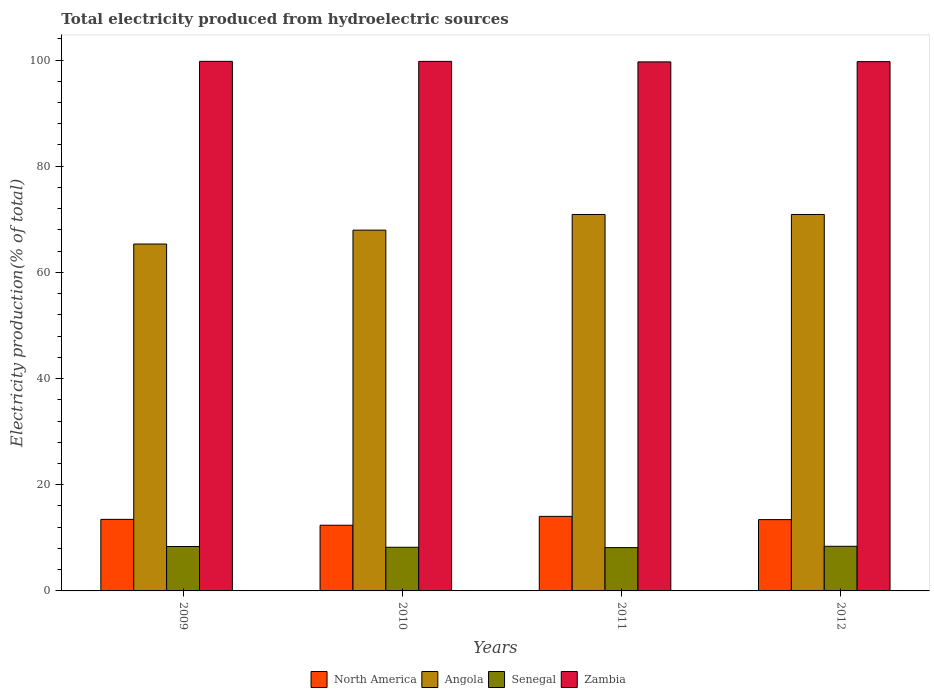How many different coloured bars are there?
Offer a very short reply. 4. How many groups of bars are there?
Offer a very short reply. 4. How many bars are there on the 2nd tick from the right?
Give a very brief answer. 4. What is the label of the 3rd group of bars from the left?
Your response must be concise. 2011. In how many cases, is the number of bars for a given year not equal to the number of legend labels?
Offer a terse response. 0. What is the total electricity produced in Senegal in 2011?
Give a very brief answer. 8.16. Across all years, what is the maximum total electricity produced in Angola?
Provide a succinct answer. 70.91. Across all years, what is the minimum total electricity produced in North America?
Your answer should be compact. 12.37. In which year was the total electricity produced in Senegal maximum?
Your response must be concise. 2012. In which year was the total electricity produced in Angola minimum?
Give a very brief answer. 2009. What is the total total electricity produced in Zambia in the graph?
Give a very brief answer. 398.84. What is the difference between the total electricity produced in Senegal in 2009 and that in 2010?
Give a very brief answer. 0.14. What is the difference between the total electricity produced in North America in 2010 and the total electricity produced in Zambia in 2012?
Keep it short and to the point. -87.32. What is the average total electricity produced in Angola per year?
Your answer should be very brief. 68.78. In the year 2011, what is the difference between the total electricity produced in Angola and total electricity produced in Senegal?
Your response must be concise. 62.75. In how many years, is the total electricity produced in North America greater than 8 %?
Offer a terse response. 4. What is the ratio of the total electricity produced in Angola in 2010 to that in 2012?
Your response must be concise. 0.96. Is the difference between the total electricity produced in Angola in 2010 and 2012 greater than the difference between the total electricity produced in Senegal in 2010 and 2012?
Your answer should be compact. No. What is the difference between the highest and the second highest total electricity produced in Zambia?
Your response must be concise. 0.01. What is the difference between the highest and the lowest total electricity produced in North America?
Your answer should be very brief. 1.67. Is the sum of the total electricity produced in Zambia in 2009 and 2012 greater than the maximum total electricity produced in Angola across all years?
Your response must be concise. Yes. What does the 3rd bar from the left in 2010 represents?
Your response must be concise. Senegal. What does the 3rd bar from the right in 2012 represents?
Keep it short and to the point. Angola. Is it the case that in every year, the sum of the total electricity produced in Angola and total electricity produced in Senegal is greater than the total electricity produced in North America?
Offer a terse response. Yes. How many bars are there?
Give a very brief answer. 16. How many years are there in the graph?
Make the answer very short. 4. Does the graph contain any zero values?
Keep it short and to the point. No. Does the graph contain grids?
Your response must be concise. No. Where does the legend appear in the graph?
Your answer should be very brief. Bottom center. How many legend labels are there?
Make the answer very short. 4. How are the legend labels stacked?
Provide a short and direct response. Horizontal. What is the title of the graph?
Your answer should be very brief. Total electricity produced from hydroelectric sources. Does "Cyprus" appear as one of the legend labels in the graph?
Give a very brief answer. No. What is the Electricity production(% of total) in North America in 2009?
Your answer should be compact. 13.48. What is the Electricity production(% of total) of Angola in 2009?
Offer a very short reply. 65.34. What is the Electricity production(% of total) in Senegal in 2009?
Provide a succinct answer. 8.36. What is the Electricity production(% of total) in Zambia in 2009?
Offer a terse response. 99.75. What is the Electricity production(% of total) of North America in 2010?
Your answer should be very brief. 12.37. What is the Electricity production(% of total) in Angola in 2010?
Provide a short and direct response. 67.96. What is the Electricity production(% of total) in Senegal in 2010?
Offer a very short reply. 8.22. What is the Electricity production(% of total) in Zambia in 2010?
Provide a succinct answer. 99.74. What is the Electricity production(% of total) in North America in 2011?
Your response must be concise. 14.04. What is the Electricity production(% of total) in Angola in 2011?
Make the answer very short. 70.91. What is the Electricity production(% of total) of Senegal in 2011?
Ensure brevity in your answer.  8.16. What is the Electricity production(% of total) of Zambia in 2011?
Give a very brief answer. 99.65. What is the Electricity production(% of total) of North America in 2012?
Provide a short and direct response. 13.43. What is the Electricity production(% of total) in Angola in 2012?
Make the answer very short. 70.91. What is the Electricity production(% of total) in Senegal in 2012?
Offer a very short reply. 8.41. What is the Electricity production(% of total) of Zambia in 2012?
Provide a succinct answer. 99.7. Across all years, what is the maximum Electricity production(% of total) of North America?
Ensure brevity in your answer.  14.04. Across all years, what is the maximum Electricity production(% of total) in Angola?
Make the answer very short. 70.91. Across all years, what is the maximum Electricity production(% of total) in Senegal?
Your response must be concise. 8.41. Across all years, what is the maximum Electricity production(% of total) of Zambia?
Your answer should be very brief. 99.75. Across all years, what is the minimum Electricity production(% of total) in North America?
Your response must be concise. 12.37. Across all years, what is the minimum Electricity production(% of total) in Angola?
Offer a very short reply. 65.34. Across all years, what is the minimum Electricity production(% of total) of Senegal?
Offer a terse response. 8.16. Across all years, what is the minimum Electricity production(% of total) in Zambia?
Your response must be concise. 99.65. What is the total Electricity production(% of total) of North America in the graph?
Give a very brief answer. 53.32. What is the total Electricity production(% of total) in Angola in the graph?
Offer a very short reply. 275.12. What is the total Electricity production(% of total) in Senegal in the graph?
Ensure brevity in your answer.  33.15. What is the total Electricity production(% of total) of Zambia in the graph?
Keep it short and to the point. 398.84. What is the difference between the Electricity production(% of total) of North America in 2009 and that in 2010?
Your answer should be compact. 1.11. What is the difference between the Electricity production(% of total) in Angola in 2009 and that in 2010?
Provide a short and direct response. -2.61. What is the difference between the Electricity production(% of total) of Senegal in 2009 and that in 2010?
Ensure brevity in your answer.  0.14. What is the difference between the Electricity production(% of total) of Zambia in 2009 and that in 2010?
Offer a terse response. 0.01. What is the difference between the Electricity production(% of total) of North America in 2009 and that in 2011?
Ensure brevity in your answer.  -0.56. What is the difference between the Electricity production(% of total) in Angola in 2009 and that in 2011?
Your answer should be compact. -5.56. What is the difference between the Electricity production(% of total) in Senegal in 2009 and that in 2011?
Keep it short and to the point. 0.21. What is the difference between the Electricity production(% of total) in Zambia in 2009 and that in 2011?
Your answer should be compact. 0.1. What is the difference between the Electricity production(% of total) in North America in 2009 and that in 2012?
Keep it short and to the point. 0.05. What is the difference between the Electricity production(% of total) of Angola in 2009 and that in 2012?
Provide a short and direct response. -5.56. What is the difference between the Electricity production(% of total) in Senegal in 2009 and that in 2012?
Your answer should be very brief. -0.04. What is the difference between the Electricity production(% of total) of Zambia in 2009 and that in 2012?
Ensure brevity in your answer.  0.05. What is the difference between the Electricity production(% of total) in North America in 2010 and that in 2011?
Keep it short and to the point. -1.67. What is the difference between the Electricity production(% of total) of Angola in 2010 and that in 2011?
Give a very brief answer. -2.95. What is the difference between the Electricity production(% of total) in Senegal in 2010 and that in 2011?
Your answer should be very brief. 0.07. What is the difference between the Electricity production(% of total) of Zambia in 2010 and that in 2011?
Provide a short and direct response. 0.09. What is the difference between the Electricity production(% of total) in North America in 2010 and that in 2012?
Give a very brief answer. -1.06. What is the difference between the Electricity production(% of total) in Angola in 2010 and that in 2012?
Keep it short and to the point. -2.95. What is the difference between the Electricity production(% of total) in Senegal in 2010 and that in 2012?
Ensure brevity in your answer.  -0.18. What is the difference between the Electricity production(% of total) of Zambia in 2010 and that in 2012?
Provide a short and direct response. 0.05. What is the difference between the Electricity production(% of total) of North America in 2011 and that in 2012?
Make the answer very short. 0.61. What is the difference between the Electricity production(% of total) of Angola in 2011 and that in 2012?
Keep it short and to the point. 0. What is the difference between the Electricity production(% of total) of Senegal in 2011 and that in 2012?
Offer a very short reply. -0.25. What is the difference between the Electricity production(% of total) in Zambia in 2011 and that in 2012?
Offer a very short reply. -0.04. What is the difference between the Electricity production(% of total) of North America in 2009 and the Electricity production(% of total) of Angola in 2010?
Offer a terse response. -54.48. What is the difference between the Electricity production(% of total) in North America in 2009 and the Electricity production(% of total) in Senegal in 2010?
Provide a short and direct response. 5.25. What is the difference between the Electricity production(% of total) of North America in 2009 and the Electricity production(% of total) of Zambia in 2010?
Offer a very short reply. -86.26. What is the difference between the Electricity production(% of total) of Angola in 2009 and the Electricity production(% of total) of Senegal in 2010?
Provide a short and direct response. 57.12. What is the difference between the Electricity production(% of total) in Angola in 2009 and the Electricity production(% of total) in Zambia in 2010?
Provide a short and direct response. -34.4. What is the difference between the Electricity production(% of total) in Senegal in 2009 and the Electricity production(% of total) in Zambia in 2010?
Your response must be concise. -91.38. What is the difference between the Electricity production(% of total) of North America in 2009 and the Electricity production(% of total) of Angola in 2011?
Provide a succinct answer. -57.43. What is the difference between the Electricity production(% of total) in North America in 2009 and the Electricity production(% of total) in Senegal in 2011?
Provide a short and direct response. 5.32. What is the difference between the Electricity production(% of total) of North America in 2009 and the Electricity production(% of total) of Zambia in 2011?
Ensure brevity in your answer.  -86.17. What is the difference between the Electricity production(% of total) in Angola in 2009 and the Electricity production(% of total) in Senegal in 2011?
Offer a very short reply. 57.19. What is the difference between the Electricity production(% of total) of Angola in 2009 and the Electricity production(% of total) of Zambia in 2011?
Provide a succinct answer. -34.31. What is the difference between the Electricity production(% of total) in Senegal in 2009 and the Electricity production(% of total) in Zambia in 2011?
Make the answer very short. -91.29. What is the difference between the Electricity production(% of total) in North America in 2009 and the Electricity production(% of total) in Angola in 2012?
Give a very brief answer. -57.43. What is the difference between the Electricity production(% of total) of North America in 2009 and the Electricity production(% of total) of Senegal in 2012?
Ensure brevity in your answer.  5.07. What is the difference between the Electricity production(% of total) in North America in 2009 and the Electricity production(% of total) in Zambia in 2012?
Your response must be concise. -86.22. What is the difference between the Electricity production(% of total) in Angola in 2009 and the Electricity production(% of total) in Senegal in 2012?
Provide a short and direct response. 56.94. What is the difference between the Electricity production(% of total) of Angola in 2009 and the Electricity production(% of total) of Zambia in 2012?
Provide a succinct answer. -34.35. What is the difference between the Electricity production(% of total) of Senegal in 2009 and the Electricity production(% of total) of Zambia in 2012?
Offer a very short reply. -91.33. What is the difference between the Electricity production(% of total) in North America in 2010 and the Electricity production(% of total) in Angola in 2011?
Keep it short and to the point. -58.53. What is the difference between the Electricity production(% of total) of North America in 2010 and the Electricity production(% of total) of Senegal in 2011?
Offer a terse response. 4.22. What is the difference between the Electricity production(% of total) of North America in 2010 and the Electricity production(% of total) of Zambia in 2011?
Your answer should be compact. -87.28. What is the difference between the Electricity production(% of total) of Angola in 2010 and the Electricity production(% of total) of Senegal in 2011?
Provide a short and direct response. 59.8. What is the difference between the Electricity production(% of total) in Angola in 2010 and the Electricity production(% of total) in Zambia in 2011?
Offer a terse response. -31.69. What is the difference between the Electricity production(% of total) in Senegal in 2010 and the Electricity production(% of total) in Zambia in 2011?
Your response must be concise. -91.43. What is the difference between the Electricity production(% of total) in North America in 2010 and the Electricity production(% of total) in Angola in 2012?
Make the answer very short. -58.53. What is the difference between the Electricity production(% of total) of North America in 2010 and the Electricity production(% of total) of Senegal in 2012?
Keep it short and to the point. 3.97. What is the difference between the Electricity production(% of total) of North America in 2010 and the Electricity production(% of total) of Zambia in 2012?
Give a very brief answer. -87.32. What is the difference between the Electricity production(% of total) in Angola in 2010 and the Electricity production(% of total) in Senegal in 2012?
Give a very brief answer. 59.55. What is the difference between the Electricity production(% of total) of Angola in 2010 and the Electricity production(% of total) of Zambia in 2012?
Your answer should be very brief. -31.74. What is the difference between the Electricity production(% of total) of Senegal in 2010 and the Electricity production(% of total) of Zambia in 2012?
Offer a terse response. -91.47. What is the difference between the Electricity production(% of total) of North America in 2011 and the Electricity production(% of total) of Angola in 2012?
Ensure brevity in your answer.  -56.86. What is the difference between the Electricity production(% of total) of North America in 2011 and the Electricity production(% of total) of Senegal in 2012?
Provide a succinct answer. 5.64. What is the difference between the Electricity production(% of total) of North America in 2011 and the Electricity production(% of total) of Zambia in 2012?
Keep it short and to the point. -85.65. What is the difference between the Electricity production(% of total) of Angola in 2011 and the Electricity production(% of total) of Senegal in 2012?
Your answer should be very brief. 62.5. What is the difference between the Electricity production(% of total) in Angola in 2011 and the Electricity production(% of total) in Zambia in 2012?
Ensure brevity in your answer.  -28.79. What is the difference between the Electricity production(% of total) of Senegal in 2011 and the Electricity production(% of total) of Zambia in 2012?
Make the answer very short. -91.54. What is the average Electricity production(% of total) in North America per year?
Make the answer very short. 13.33. What is the average Electricity production(% of total) of Angola per year?
Ensure brevity in your answer.  68.78. What is the average Electricity production(% of total) of Senegal per year?
Ensure brevity in your answer.  8.29. What is the average Electricity production(% of total) of Zambia per year?
Your answer should be very brief. 99.71. In the year 2009, what is the difference between the Electricity production(% of total) of North America and Electricity production(% of total) of Angola?
Make the answer very short. -51.86. In the year 2009, what is the difference between the Electricity production(% of total) in North America and Electricity production(% of total) in Senegal?
Provide a succinct answer. 5.12. In the year 2009, what is the difference between the Electricity production(% of total) in North America and Electricity production(% of total) in Zambia?
Your answer should be very brief. -86.27. In the year 2009, what is the difference between the Electricity production(% of total) of Angola and Electricity production(% of total) of Senegal?
Keep it short and to the point. 56.98. In the year 2009, what is the difference between the Electricity production(% of total) of Angola and Electricity production(% of total) of Zambia?
Ensure brevity in your answer.  -34.41. In the year 2009, what is the difference between the Electricity production(% of total) in Senegal and Electricity production(% of total) in Zambia?
Your response must be concise. -91.39. In the year 2010, what is the difference between the Electricity production(% of total) in North America and Electricity production(% of total) in Angola?
Offer a very short reply. -55.58. In the year 2010, what is the difference between the Electricity production(% of total) in North America and Electricity production(% of total) in Senegal?
Keep it short and to the point. 4.15. In the year 2010, what is the difference between the Electricity production(% of total) of North America and Electricity production(% of total) of Zambia?
Your response must be concise. -87.37. In the year 2010, what is the difference between the Electricity production(% of total) in Angola and Electricity production(% of total) in Senegal?
Make the answer very short. 59.73. In the year 2010, what is the difference between the Electricity production(% of total) of Angola and Electricity production(% of total) of Zambia?
Provide a succinct answer. -31.79. In the year 2010, what is the difference between the Electricity production(% of total) in Senegal and Electricity production(% of total) in Zambia?
Offer a terse response. -91.52. In the year 2011, what is the difference between the Electricity production(% of total) in North America and Electricity production(% of total) in Angola?
Provide a short and direct response. -56.87. In the year 2011, what is the difference between the Electricity production(% of total) of North America and Electricity production(% of total) of Senegal?
Ensure brevity in your answer.  5.89. In the year 2011, what is the difference between the Electricity production(% of total) in North America and Electricity production(% of total) in Zambia?
Ensure brevity in your answer.  -85.61. In the year 2011, what is the difference between the Electricity production(% of total) of Angola and Electricity production(% of total) of Senegal?
Your response must be concise. 62.75. In the year 2011, what is the difference between the Electricity production(% of total) in Angola and Electricity production(% of total) in Zambia?
Your response must be concise. -28.74. In the year 2011, what is the difference between the Electricity production(% of total) in Senegal and Electricity production(% of total) in Zambia?
Provide a succinct answer. -91.5. In the year 2012, what is the difference between the Electricity production(% of total) in North America and Electricity production(% of total) in Angola?
Your answer should be compact. -57.48. In the year 2012, what is the difference between the Electricity production(% of total) in North America and Electricity production(% of total) in Senegal?
Offer a terse response. 5.02. In the year 2012, what is the difference between the Electricity production(% of total) of North America and Electricity production(% of total) of Zambia?
Your response must be concise. -86.27. In the year 2012, what is the difference between the Electricity production(% of total) of Angola and Electricity production(% of total) of Senegal?
Provide a succinct answer. 62.5. In the year 2012, what is the difference between the Electricity production(% of total) of Angola and Electricity production(% of total) of Zambia?
Keep it short and to the point. -28.79. In the year 2012, what is the difference between the Electricity production(% of total) in Senegal and Electricity production(% of total) in Zambia?
Provide a succinct answer. -91.29. What is the ratio of the Electricity production(% of total) in North America in 2009 to that in 2010?
Give a very brief answer. 1.09. What is the ratio of the Electricity production(% of total) of Angola in 2009 to that in 2010?
Offer a terse response. 0.96. What is the ratio of the Electricity production(% of total) in Senegal in 2009 to that in 2010?
Offer a very short reply. 1.02. What is the ratio of the Electricity production(% of total) of Zambia in 2009 to that in 2010?
Provide a short and direct response. 1. What is the ratio of the Electricity production(% of total) of North America in 2009 to that in 2011?
Make the answer very short. 0.96. What is the ratio of the Electricity production(% of total) of Angola in 2009 to that in 2011?
Keep it short and to the point. 0.92. What is the ratio of the Electricity production(% of total) of Senegal in 2009 to that in 2011?
Offer a very short reply. 1.03. What is the ratio of the Electricity production(% of total) of Angola in 2009 to that in 2012?
Your response must be concise. 0.92. What is the ratio of the Electricity production(% of total) in Senegal in 2009 to that in 2012?
Your answer should be very brief. 0.99. What is the ratio of the Electricity production(% of total) of North America in 2010 to that in 2011?
Your answer should be compact. 0.88. What is the ratio of the Electricity production(% of total) in Angola in 2010 to that in 2011?
Ensure brevity in your answer.  0.96. What is the ratio of the Electricity production(% of total) of Senegal in 2010 to that in 2011?
Your response must be concise. 1.01. What is the ratio of the Electricity production(% of total) in Zambia in 2010 to that in 2011?
Give a very brief answer. 1. What is the ratio of the Electricity production(% of total) of North America in 2010 to that in 2012?
Keep it short and to the point. 0.92. What is the ratio of the Electricity production(% of total) in Angola in 2010 to that in 2012?
Keep it short and to the point. 0.96. What is the ratio of the Electricity production(% of total) of Senegal in 2010 to that in 2012?
Offer a terse response. 0.98. What is the ratio of the Electricity production(% of total) in Zambia in 2010 to that in 2012?
Your response must be concise. 1. What is the ratio of the Electricity production(% of total) in North America in 2011 to that in 2012?
Your answer should be compact. 1.05. What is the ratio of the Electricity production(% of total) in Senegal in 2011 to that in 2012?
Ensure brevity in your answer.  0.97. What is the ratio of the Electricity production(% of total) of Zambia in 2011 to that in 2012?
Your answer should be very brief. 1. What is the difference between the highest and the second highest Electricity production(% of total) of North America?
Offer a terse response. 0.56. What is the difference between the highest and the second highest Electricity production(% of total) in Angola?
Your answer should be very brief. 0. What is the difference between the highest and the second highest Electricity production(% of total) of Senegal?
Offer a terse response. 0.04. What is the difference between the highest and the second highest Electricity production(% of total) of Zambia?
Ensure brevity in your answer.  0.01. What is the difference between the highest and the lowest Electricity production(% of total) of North America?
Make the answer very short. 1.67. What is the difference between the highest and the lowest Electricity production(% of total) in Angola?
Your answer should be compact. 5.56. What is the difference between the highest and the lowest Electricity production(% of total) in Senegal?
Make the answer very short. 0.25. What is the difference between the highest and the lowest Electricity production(% of total) in Zambia?
Offer a very short reply. 0.1. 